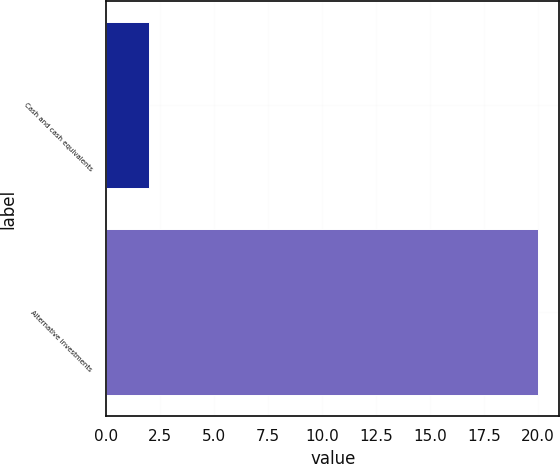<chart> <loc_0><loc_0><loc_500><loc_500><bar_chart><fcel>Cash and cash equivalents<fcel>Alternative investments<nl><fcel>2<fcel>20<nl></chart> 